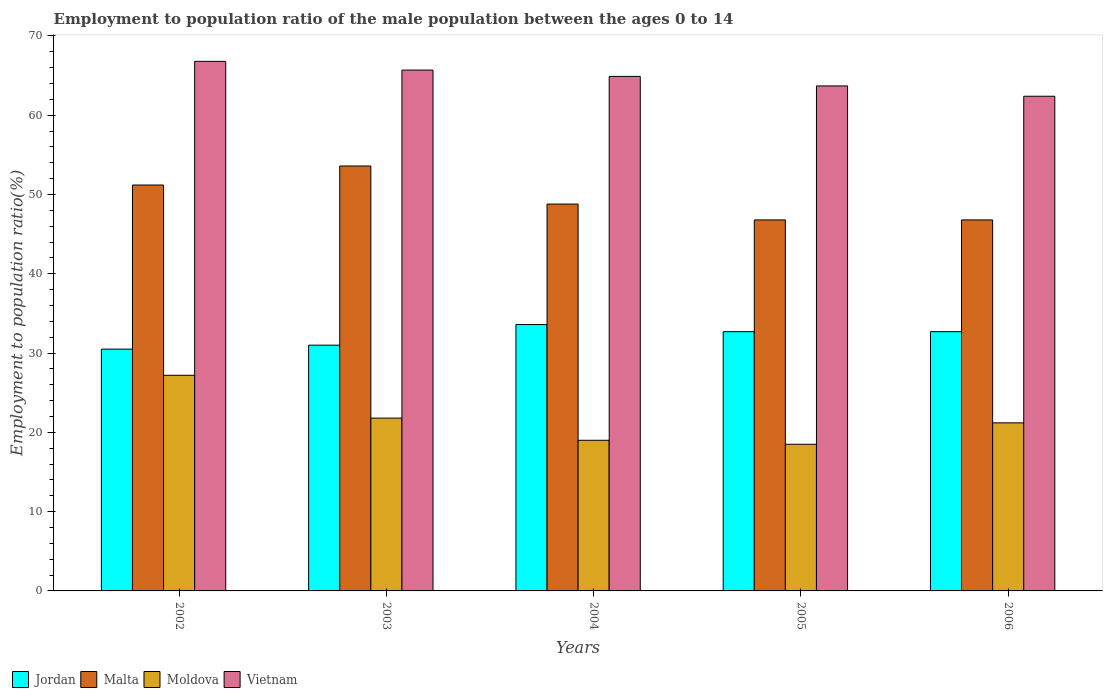How many groups of bars are there?
Your answer should be compact. 5. Are the number of bars per tick equal to the number of legend labels?
Your response must be concise. Yes. Are the number of bars on each tick of the X-axis equal?
Offer a very short reply. Yes. How many bars are there on the 3rd tick from the left?
Ensure brevity in your answer.  4. What is the employment to population ratio in Jordan in 2002?
Make the answer very short. 30.5. Across all years, what is the maximum employment to population ratio in Vietnam?
Your answer should be compact. 66.8. Across all years, what is the minimum employment to population ratio in Moldova?
Your response must be concise. 18.5. What is the total employment to population ratio in Vietnam in the graph?
Your answer should be compact. 323.5. What is the difference between the employment to population ratio in Jordan in 2003 and that in 2005?
Provide a short and direct response. -1.7. What is the difference between the employment to population ratio in Jordan in 2006 and the employment to population ratio in Vietnam in 2004?
Keep it short and to the point. -32.2. What is the average employment to population ratio in Moldova per year?
Your answer should be very brief. 21.54. In the year 2003, what is the difference between the employment to population ratio in Vietnam and employment to population ratio in Jordan?
Offer a very short reply. 34.7. What is the ratio of the employment to population ratio in Vietnam in 2002 to that in 2003?
Offer a very short reply. 1.02. Is the difference between the employment to population ratio in Vietnam in 2002 and 2004 greater than the difference between the employment to population ratio in Jordan in 2002 and 2004?
Provide a short and direct response. Yes. What is the difference between the highest and the second highest employment to population ratio in Moldova?
Ensure brevity in your answer.  5.4. What is the difference between the highest and the lowest employment to population ratio in Jordan?
Give a very brief answer. 3.1. In how many years, is the employment to population ratio in Malta greater than the average employment to population ratio in Malta taken over all years?
Offer a very short reply. 2. Is it the case that in every year, the sum of the employment to population ratio in Malta and employment to population ratio in Vietnam is greater than the sum of employment to population ratio in Jordan and employment to population ratio in Moldova?
Give a very brief answer. Yes. What does the 2nd bar from the left in 2002 represents?
Offer a terse response. Malta. What does the 1st bar from the right in 2003 represents?
Offer a terse response. Vietnam. Is it the case that in every year, the sum of the employment to population ratio in Malta and employment to population ratio in Moldova is greater than the employment to population ratio in Jordan?
Ensure brevity in your answer.  Yes. How many bars are there?
Provide a succinct answer. 20. Are all the bars in the graph horizontal?
Offer a very short reply. No. Are the values on the major ticks of Y-axis written in scientific E-notation?
Offer a terse response. No. Does the graph contain any zero values?
Offer a terse response. No. Does the graph contain grids?
Your response must be concise. No. What is the title of the graph?
Ensure brevity in your answer.  Employment to population ratio of the male population between the ages 0 to 14. Does "Korea (Republic)" appear as one of the legend labels in the graph?
Your answer should be very brief. No. What is the label or title of the X-axis?
Offer a terse response. Years. What is the Employment to population ratio(%) of Jordan in 2002?
Ensure brevity in your answer.  30.5. What is the Employment to population ratio(%) of Malta in 2002?
Make the answer very short. 51.2. What is the Employment to population ratio(%) of Moldova in 2002?
Your answer should be very brief. 27.2. What is the Employment to population ratio(%) of Vietnam in 2002?
Provide a short and direct response. 66.8. What is the Employment to population ratio(%) of Jordan in 2003?
Offer a terse response. 31. What is the Employment to population ratio(%) in Malta in 2003?
Offer a terse response. 53.6. What is the Employment to population ratio(%) in Moldova in 2003?
Keep it short and to the point. 21.8. What is the Employment to population ratio(%) of Vietnam in 2003?
Make the answer very short. 65.7. What is the Employment to population ratio(%) of Jordan in 2004?
Provide a succinct answer. 33.6. What is the Employment to population ratio(%) of Malta in 2004?
Make the answer very short. 48.8. What is the Employment to population ratio(%) of Moldova in 2004?
Keep it short and to the point. 19. What is the Employment to population ratio(%) in Vietnam in 2004?
Your response must be concise. 64.9. What is the Employment to population ratio(%) of Jordan in 2005?
Your answer should be very brief. 32.7. What is the Employment to population ratio(%) in Malta in 2005?
Ensure brevity in your answer.  46.8. What is the Employment to population ratio(%) of Vietnam in 2005?
Your answer should be compact. 63.7. What is the Employment to population ratio(%) of Jordan in 2006?
Offer a very short reply. 32.7. What is the Employment to population ratio(%) in Malta in 2006?
Your answer should be very brief. 46.8. What is the Employment to population ratio(%) of Moldova in 2006?
Your answer should be very brief. 21.2. What is the Employment to population ratio(%) of Vietnam in 2006?
Provide a succinct answer. 62.4. Across all years, what is the maximum Employment to population ratio(%) in Jordan?
Provide a short and direct response. 33.6. Across all years, what is the maximum Employment to population ratio(%) in Malta?
Your response must be concise. 53.6. Across all years, what is the maximum Employment to population ratio(%) of Moldova?
Offer a terse response. 27.2. Across all years, what is the maximum Employment to population ratio(%) in Vietnam?
Offer a terse response. 66.8. Across all years, what is the minimum Employment to population ratio(%) of Jordan?
Keep it short and to the point. 30.5. Across all years, what is the minimum Employment to population ratio(%) of Malta?
Give a very brief answer. 46.8. Across all years, what is the minimum Employment to population ratio(%) in Vietnam?
Your answer should be compact. 62.4. What is the total Employment to population ratio(%) in Jordan in the graph?
Make the answer very short. 160.5. What is the total Employment to population ratio(%) of Malta in the graph?
Provide a short and direct response. 247.2. What is the total Employment to population ratio(%) of Moldova in the graph?
Your response must be concise. 107.7. What is the total Employment to population ratio(%) of Vietnam in the graph?
Your answer should be very brief. 323.5. What is the difference between the Employment to population ratio(%) of Jordan in 2002 and that in 2003?
Provide a succinct answer. -0.5. What is the difference between the Employment to population ratio(%) in Malta in 2002 and that in 2003?
Provide a succinct answer. -2.4. What is the difference between the Employment to population ratio(%) of Moldova in 2002 and that in 2003?
Make the answer very short. 5.4. What is the difference between the Employment to population ratio(%) of Jordan in 2002 and that in 2004?
Make the answer very short. -3.1. What is the difference between the Employment to population ratio(%) of Malta in 2002 and that in 2005?
Your answer should be compact. 4.4. What is the difference between the Employment to population ratio(%) in Vietnam in 2002 and that in 2005?
Give a very brief answer. 3.1. What is the difference between the Employment to population ratio(%) in Jordan in 2002 and that in 2006?
Keep it short and to the point. -2.2. What is the difference between the Employment to population ratio(%) in Vietnam in 2002 and that in 2006?
Your answer should be very brief. 4.4. What is the difference between the Employment to population ratio(%) in Jordan in 2003 and that in 2004?
Offer a very short reply. -2.6. What is the difference between the Employment to population ratio(%) in Malta in 2003 and that in 2004?
Give a very brief answer. 4.8. What is the difference between the Employment to population ratio(%) in Vietnam in 2003 and that in 2004?
Ensure brevity in your answer.  0.8. What is the difference between the Employment to population ratio(%) of Jordan in 2003 and that in 2005?
Your answer should be very brief. -1.7. What is the difference between the Employment to population ratio(%) of Moldova in 2003 and that in 2005?
Make the answer very short. 3.3. What is the difference between the Employment to population ratio(%) in Jordan in 2003 and that in 2006?
Your answer should be very brief. -1.7. What is the difference between the Employment to population ratio(%) in Vietnam in 2004 and that in 2005?
Your response must be concise. 1.2. What is the difference between the Employment to population ratio(%) in Malta in 2004 and that in 2006?
Your answer should be very brief. 2. What is the difference between the Employment to population ratio(%) of Malta in 2005 and that in 2006?
Provide a short and direct response. 0. What is the difference between the Employment to population ratio(%) in Moldova in 2005 and that in 2006?
Your answer should be compact. -2.7. What is the difference between the Employment to population ratio(%) in Jordan in 2002 and the Employment to population ratio(%) in Malta in 2003?
Your answer should be compact. -23.1. What is the difference between the Employment to population ratio(%) in Jordan in 2002 and the Employment to population ratio(%) in Vietnam in 2003?
Provide a short and direct response. -35.2. What is the difference between the Employment to population ratio(%) in Malta in 2002 and the Employment to population ratio(%) in Moldova in 2003?
Your answer should be compact. 29.4. What is the difference between the Employment to population ratio(%) of Moldova in 2002 and the Employment to population ratio(%) of Vietnam in 2003?
Keep it short and to the point. -38.5. What is the difference between the Employment to population ratio(%) of Jordan in 2002 and the Employment to population ratio(%) of Malta in 2004?
Your response must be concise. -18.3. What is the difference between the Employment to population ratio(%) in Jordan in 2002 and the Employment to population ratio(%) in Vietnam in 2004?
Your answer should be compact. -34.4. What is the difference between the Employment to population ratio(%) in Malta in 2002 and the Employment to population ratio(%) in Moldova in 2004?
Provide a succinct answer. 32.2. What is the difference between the Employment to population ratio(%) of Malta in 2002 and the Employment to population ratio(%) of Vietnam in 2004?
Make the answer very short. -13.7. What is the difference between the Employment to population ratio(%) of Moldova in 2002 and the Employment to population ratio(%) of Vietnam in 2004?
Give a very brief answer. -37.7. What is the difference between the Employment to population ratio(%) of Jordan in 2002 and the Employment to population ratio(%) of Malta in 2005?
Offer a very short reply. -16.3. What is the difference between the Employment to population ratio(%) of Jordan in 2002 and the Employment to population ratio(%) of Moldova in 2005?
Make the answer very short. 12. What is the difference between the Employment to population ratio(%) of Jordan in 2002 and the Employment to population ratio(%) of Vietnam in 2005?
Make the answer very short. -33.2. What is the difference between the Employment to population ratio(%) in Malta in 2002 and the Employment to population ratio(%) in Moldova in 2005?
Offer a very short reply. 32.7. What is the difference between the Employment to population ratio(%) in Moldova in 2002 and the Employment to population ratio(%) in Vietnam in 2005?
Give a very brief answer. -36.5. What is the difference between the Employment to population ratio(%) of Jordan in 2002 and the Employment to population ratio(%) of Malta in 2006?
Offer a terse response. -16.3. What is the difference between the Employment to population ratio(%) in Jordan in 2002 and the Employment to population ratio(%) in Vietnam in 2006?
Offer a very short reply. -31.9. What is the difference between the Employment to population ratio(%) in Malta in 2002 and the Employment to population ratio(%) in Vietnam in 2006?
Your answer should be very brief. -11.2. What is the difference between the Employment to population ratio(%) in Moldova in 2002 and the Employment to population ratio(%) in Vietnam in 2006?
Your answer should be very brief. -35.2. What is the difference between the Employment to population ratio(%) of Jordan in 2003 and the Employment to population ratio(%) of Malta in 2004?
Give a very brief answer. -17.8. What is the difference between the Employment to population ratio(%) in Jordan in 2003 and the Employment to population ratio(%) in Vietnam in 2004?
Provide a short and direct response. -33.9. What is the difference between the Employment to population ratio(%) in Malta in 2003 and the Employment to population ratio(%) in Moldova in 2004?
Your answer should be very brief. 34.6. What is the difference between the Employment to population ratio(%) in Malta in 2003 and the Employment to population ratio(%) in Vietnam in 2004?
Make the answer very short. -11.3. What is the difference between the Employment to population ratio(%) in Moldova in 2003 and the Employment to population ratio(%) in Vietnam in 2004?
Your answer should be compact. -43.1. What is the difference between the Employment to population ratio(%) of Jordan in 2003 and the Employment to population ratio(%) of Malta in 2005?
Make the answer very short. -15.8. What is the difference between the Employment to population ratio(%) in Jordan in 2003 and the Employment to population ratio(%) in Moldova in 2005?
Provide a succinct answer. 12.5. What is the difference between the Employment to population ratio(%) in Jordan in 2003 and the Employment to population ratio(%) in Vietnam in 2005?
Keep it short and to the point. -32.7. What is the difference between the Employment to population ratio(%) of Malta in 2003 and the Employment to population ratio(%) of Moldova in 2005?
Your answer should be compact. 35.1. What is the difference between the Employment to population ratio(%) in Moldova in 2003 and the Employment to population ratio(%) in Vietnam in 2005?
Offer a very short reply. -41.9. What is the difference between the Employment to population ratio(%) of Jordan in 2003 and the Employment to population ratio(%) of Malta in 2006?
Offer a terse response. -15.8. What is the difference between the Employment to population ratio(%) in Jordan in 2003 and the Employment to population ratio(%) in Moldova in 2006?
Ensure brevity in your answer.  9.8. What is the difference between the Employment to population ratio(%) in Jordan in 2003 and the Employment to population ratio(%) in Vietnam in 2006?
Keep it short and to the point. -31.4. What is the difference between the Employment to population ratio(%) in Malta in 2003 and the Employment to population ratio(%) in Moldova in 2006?
Keep it short and to the point. 32.4. What is the difference between the Employment to population ratio(%) of Moldova in 2003 and the Employment to population ratio(%) of Vietnam in 2006?
Provide a succinct answer. -40.6. What is the difference between the Employment to population ratio(%) of Jordan in 2004 and the Employment to population ratio(%) of Moldova in 2005?
Keep it short and to the point. 15.1. What is the difference between the Employment to population ratio(%) of Jordan in 2004 and the Employment to population ratio(%) of Vietnam in 2005?
Your answer should be very brief. -30.1. What is the difference between the Employment to population ratio(%) of Malta in 2004 and the Employment to population ratio(%) of Moldova in 2005?
Offer a very short reply. 30.3. What is the difference between the Employment to population ratio(%) of Malta in 2004 and the Employment to population ratio(%) of Vietnam in 2005?
Ensure brevity in your answer.  -14.9. What is the difference between the Employment to population ratio(%) of Moldova in 2004 and the Employment to population ratio(%) of Vietnam in 2005?
Offer a terse response. -44.7. What is the difference between the Employment to population ratio(%) of Jordan in 2004 and the Employment to population ratio(%) of Malta in 2006?
Provide a short and direct response. -13.2. What is the difference between the Employment to population ratio(%) in Jordan in 2004 and the Employment to population ratio(%) in Moldova in 2006?
Offer a terse response. 12.4. What is the difference between the Employment to population ratio(%) of Jordan in 2004 and the Employment to population ratio(%) of Vietnam in 2006?
Provide a succinct answer. -28.8. What is the difference between the Employment to population ratio(%) of Malta in 2004 and the Employment to population ratio(%) of Moldova in 2006?
Ensure brevity in your answer.  27.6. What is the difference between the Employment to population ratio(%) in Moldova in 2004 and the Employment to population ratio(%) in Vietnam in 2006?
Give a very brief answer. -43.4. What is the difference between the Employment to population ratio(%) in Jordan in 2005 and the Employment to population ratio(%) in Malta in 2006?
Keep it short and to the point. -14.1. What is the difference between the Employment to population ratio(%) of Jordan in 2005 and the Employment to population ratio(%) of Vietnam in 2006?
Provide a succinct answer. -29.7. What is the difference between the Employment to population ratio(%) in Malta in 2005 and the Employment to population ratio(%) in Moldova in 2006?
Your answer should be very brief. 25.6. What is the difference between the Employment to population ratio(%) of Malta in 2005 and the Employment to population ratio(%) of Vietnam in 2006?
Ensure brevity in your answer.  -15.6. What is the difference between the Employment to population ratio(%) of Moldova in 2005 and the Employment to population ratio(%) of Vietnam in 2006?
Your answer should be very brief. -43.9. What is the average Employment to population ratio(%) of Jordan per year?
Make the answer very short. 32.1. What is the average Employment to population ratio(%) of Malta per year?
Offer a very short reply. 49.44. What is the average Employment to population ratio(%) of Moldova per year?
Offer a terse response. 21.54. What is the average Employment to population ratio(%) in Vietnam per year?
Your answer should be very brief. 64.7. In the year 2002, what is the difference between the Employment to population ratio(%) in Jordan and Employment to population ratio(%) in Malta?
Offer a terse response. -20.7. In the year 2002, what is the difference between the Employment to population ratio(%) of Jordan and Employment to population ratio(%) of Vietnam?
Keep it short and to the point. -36.3. In the year 2002, what is the difference between the Employment to population ratio(%) in Malta and Employment to population ratio(%) in Vietnam?
Your answer should be very brief. -15.6. In the year 2002, what is the difference between the Employment to population ratio(%) of Moldova and Employment to population ratio(%) of Vietnam?
Give a very brief answer. -39.6. In the year 2003, what is the difference between the Employment to population ratio(%) of Jordan and Employment to population ratio(%) of Malta?
Your response must be concise. -22.6. In the year 2003, what is the difference between the Employment to population ratio(%) in Jordan and Employment to population ratio(%) in Moldova?
Make the answer very short. 9.2. In the year 2003, what is the difference between the Employment to population ratio(%) of Jordan and Employment to population ratio(%) of Vietnam?
Keep it short and to the point. -34.7. In the year 2003, what is the difference between the Employment to population ratio(%) in Malta and Employment to population ratio(%) in Moldova?
Your answer should be compact. 31.8. In the year 2003, what is the difference between the Employment to population ratio(%) in Moldova and Employment to population ratio(%) in Vietnam?
Your answer should be compact. -43.9. In the year 2004, what is the difference between the Employment to population ratio(%) of Jordan and Employment to population ratio(%) of Malta?
Offer a very short reply. -15.2. In the year 2004, what is the difference between the Employment to population ratio(%) in Jordan and Employment to population ratio(%) in Vietnam?
Provide a short and direct response. -31.3. In the year 2004, what is the difference between the Employment to population ratio(%) of Malta and Employment to population ratio(%) of Moldova?
Provide a short and direct response. 29.8. In the year 2004, what is the difference between the Employment to population ratio(%) in Malta and Employment to population ratio(%) in Vietnam?
Provide a short and direct response. -16.1. In the year 2004, what is the difference between the Employment to population ratio(%) of Moldova and Employment to population ratio(%) of Vietnam?
Your response must be concise. -45.9. In the year 2005, what is the difference between the Employment to population ratio(%) of Jordan and Employment to population ratio(%) of Malta?
Ensure brevity in your answer.  -14.1. In the year 2005, what is the difference between the Employment to population ratio(%) of Jordan and Employment to population ratio(%) of Moldova?
Provide a short and direct response. 14.2. In the year 2005, what is the difference between the Employment to population ratio(%) in Jordan and Employment to population ratio(%) in Vietnam?
Make the answer very short. -31. In the year 2005, what is the difference between the Employment to population ratio(%) in Malta and Employment to population ratio(%) in Moldova?
Provide a succinct answer. 28.3. In the year 2005, what is the difference between the Employment to population ratio(%) in Malta and Employment to population ratio(%) in Vietnam?
Give a very brief answer. -16.9. In the year 2005, what is the difference between the Employment to population ratio(%) of Moldova and Employment to population ratio(%) of Vietnam?
Offer a very short reply. -45.2. In the year 2006, what is the difference between the Employment to population ratio(%) of Jordan and Employment to population ratio(%) of Malta?
Your response must be concise. -14.1. In the year 2006, what is the difference between the Employment to population ratio(%) in Jordan and Employment to population ratio(%) in Vietnam?
Give a very brief answer. -29.7. In the year 2006, what is the difference between the Employment to population ratio(%) of Malta and Employment to population ratio(%) of Moldova?
Keep it short and to the point. 25.6. In the year 2006, what is the difference between the Employment to population ratio(%) of Malta and Employment to population ratio(%) of Vietnam?
Make the answer very short. -15.6. In the year 2006, what is the difference between the Employment to population ratio(%) of Moldova and Employment to population ratio(%) of Vietnam?
Your answer should be very brief. -41.2. What is the ratio of the Employment to population ratio(%) in Jordan in 2002 to that in 2003?
Your answer should be very brief. 0.98. What is the ratio of the Employment to population ratio(%) in Malta in 2002 to that in 2003?
Offer a very short reply. 0.96. What is the ratio of the Employment to population ratio(%) in Moldova in 2002 to that in 2003?
Ensure brevity in your answer.  1.25. What is the ratio of the Employment to population ratio(%) in Vietnam in 2002 to that in 2003?
Provide a short and direct response. 1.02. What is the ratio of the Employment to population ratio(%) in Jordan in 2002 to that in 2004?
Make the answer very short. 0.91. What is the ratio of the Employment to population ratio(%) of Malta in 2002 to that in 2004?
Give a very brief answer. 1.05. What is the ratio of the Employment to population ratio(%) of Moldova in 2002 to that in 2004?
Offer a terse response. 1.43. What is the ratio of the Employment to population ratio(%) in Vietnam in 2002 to that in 2004?
Offer a terse response. 1.03. What is the ratio of the Employment to population ratio(%) in Jordan in 2002 to that in 2005?
Your response must be concise. 0.93. What is the ratio of the Employment to population ratio(%) in Malta in 2002 to that in 2005?
Provide a succinct answer. 1.09. What is the ratio of the Employment to population ratio(%) of Moldova in 2002 to that in 2005?
Provide a short and direct response. 1.47. What is the ratio of the Employment to population ratio(%) of Vietnam in 2002 to that in 2005?
Offer a very short reply. 1.05. What is the ratio of the Employment to population ratio(%) of Jordan in 2002 to that in 2006?
Make the answer very short. 0.93. What is the ratio of the Employment to population ratio(%) in Malta in 2002 to that in 2006?
Offer a terse response. 1.09. What is the ratio of the Employment to population ratio(%) in Moldova in 2002 to that in 2006?
Your answer should be compact. 1.28. What is the ratio of the Employment to population ratio(%) of Vietnam in 2002 to that in 2006?
Keep it short and to the point. 1.07. What is the ratio of the Employment to population ratio(%) of Jordan in 2003 to that in 2004?
Offer a very short reply. 0.92. What is the ratio of the Employment to population ratio(%) in Malta in 2003 to that in 2004?
Make the answer very short. 1.1. What is the ratio of the Employment to population ratio(%) of Moldova in 2003 to that in 2004?
Offer a very short reply. 1.15. What is the ratio of the Employment to population ratio(%) of Vietnam in 2003 to that in 2004?
Your answer should be compact. 1.01. What is the ratio of the Employment to population ratio(%) of Jordan in 2003 to that in 2005?
Offer a terse response. 0.95. What is the ratio of the Employment to population ratio(%) in Malta in 2003 to that in 2005?
Ensure brevity in your answer.  1.15. What is the ratio of the Employment to population ratio(%) in Moldova in 2003 to that in 2005?
Your answer should be compact. 1.18. What is the ratio of the Employment to population ratio(%) in Vietnam in 2003 to that in 2005?
Provide a short and direct response. 1.03. What is the ratio of the Employment to population ratio(%) in Jordan in 2003 to that in 2006?
Your response must be concise. 0.95. What is the ratio of the Employment to population ratio(%) in Malta in 2003 to that in 2006?
Keep it short and to the point. 1.15. What is the ratio of the Employment to population ratio(%) in Moldova in 2003 to that in 2006?
Ensure brevity in your answer.  1.03. What is the ratio of the Employment to population ratio(%) of Vietnam in 2003 to that in 2006?
Make the answer very short. 1.05. What is the ratio of the Employment to population ratio(%) of Jordan in 2004 to that in 2005?
Your answer should be very brief. 1.03. What is the ratio of the Employment to population ratio(%) of Malta in 2004 to that in 2005?
Offer a terse response. 1.04. What is the ratio of the Employment to population ratio(%) in Moldova in 2004 to that in 2005?
Provide a short and direct response. 1.03. What is the ratio of the Employment to population ratio(%) of Vietnam in 2004 to that in 2005?
Provide a succinct answer. 1.02. What is the ratio of the Employment to population ratio(%) in Jordan in 2004 to that in 2006?
Keep it short and to the point. 1.03. What is the ratio of the Employment to population ratio(%) in Malta in 2004 to that in 2006?
Your answer should be compact. 1.04. What is the ratio of the Employment to population ratio(%) in Moldova in 2004 to that in 2006?
Make the answer very short. 0.9. What is the ratio of the Employment to population ratio(%) in Vietnam in 2004 to that in 2006?
Give a very brief answer. 1.04. What is the ratio of the Employment to population ratio(%) of Jordan in 2005 to that in 2006?
Make the answer very short. 1. What is the ratio of the Employment to population ratio(%) in Moldova in 2005 to that in 2006?
Offer a very short reply. 0.87. What is the ratio of the Employment to population ratio(%) in Vietnam in 2005 to that in 2006?
Your response must be concise. 1.02. What is the difference between the highest and the second highest Employment to population ratio(%) in Malta?
Offer a very short reply. 2.4. What is the difference between the highest and the second highest Employment to population ratio(%) of Vietnam?
Provide a short and direct response. 1.1. What is the difference between the highest and the lowest Employment to population ratio(%) of Jordan?
Offer a terse response. 3.1. What is the difference between the highest and the lowest Employment to population ratio(%) of Malta?
Make the answer very short. 6.8. What is the difference between the highest and the lowest Employment to population ratio(%) of Vietnam?
Your answer should be compact. 4.4. 